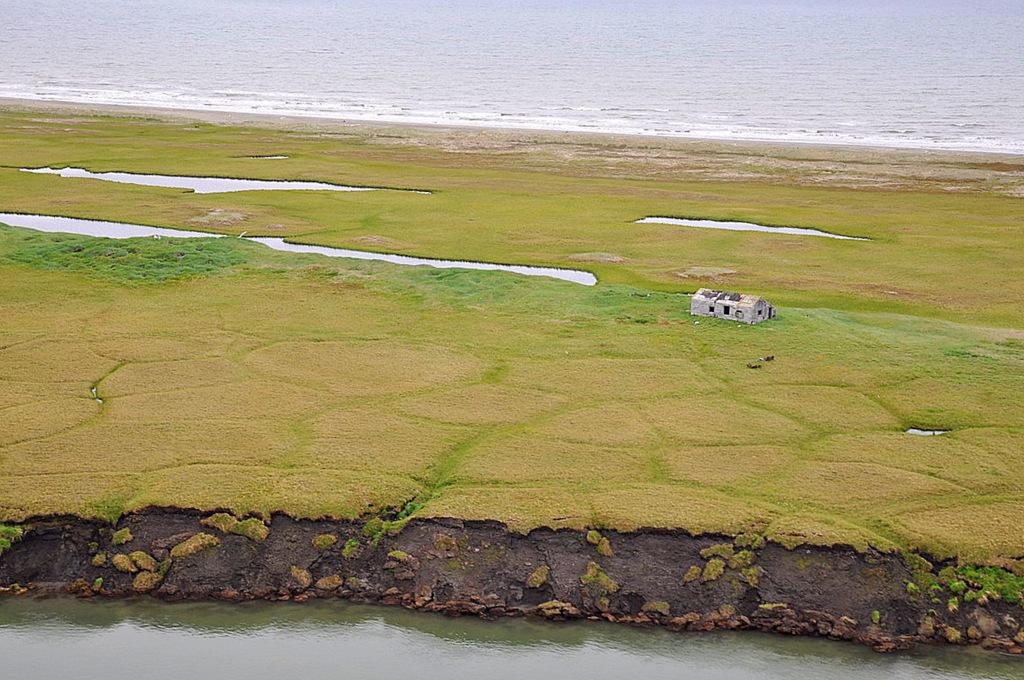What type of structure is present in the image? There is a house in the image. What type of vegetation can be seen in the image? There is grass visible in the image. What natural element is also present in the image? There is water visible in the image. What type of location is depicted in the image? The image includes a beach at the top. What type of headwear is the writer wearing in the image? There is no writer present in the image, and therefore no headwear can be observed. 